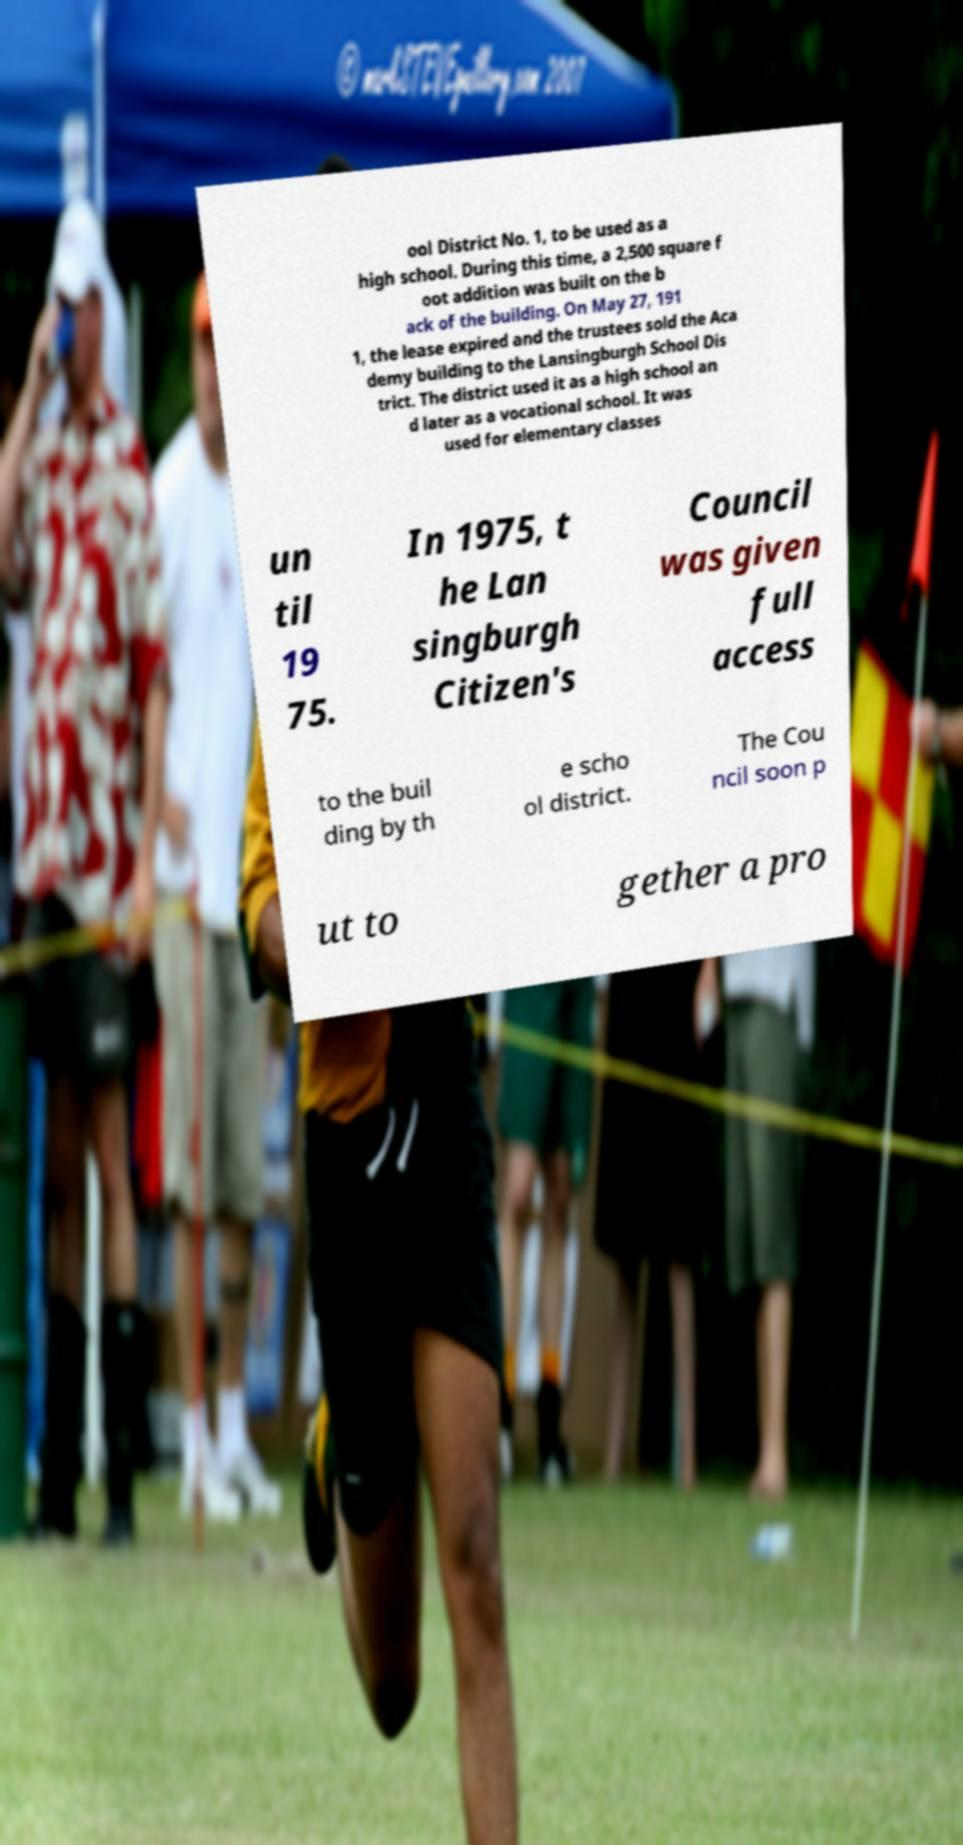Could you assist in decoding the text presented in this image and type it out clearly? ool District No. 1, to be used as a high school. During this time, a 2,500 square f oot addition was built on the b ack of the building. On May 27, 191 1, the lease expired and the trustees sold the Aca demy building to the Lansingburgh School Dis trict. The district used it as a high school an d later as a vocational school. It was used for elementary classes un til 19 75. In 1975, t he Lan singburgh Citizen's Council was given full access to the buil ding by th e scho ol district. The Cou ncil soon p ut to gether a pro 